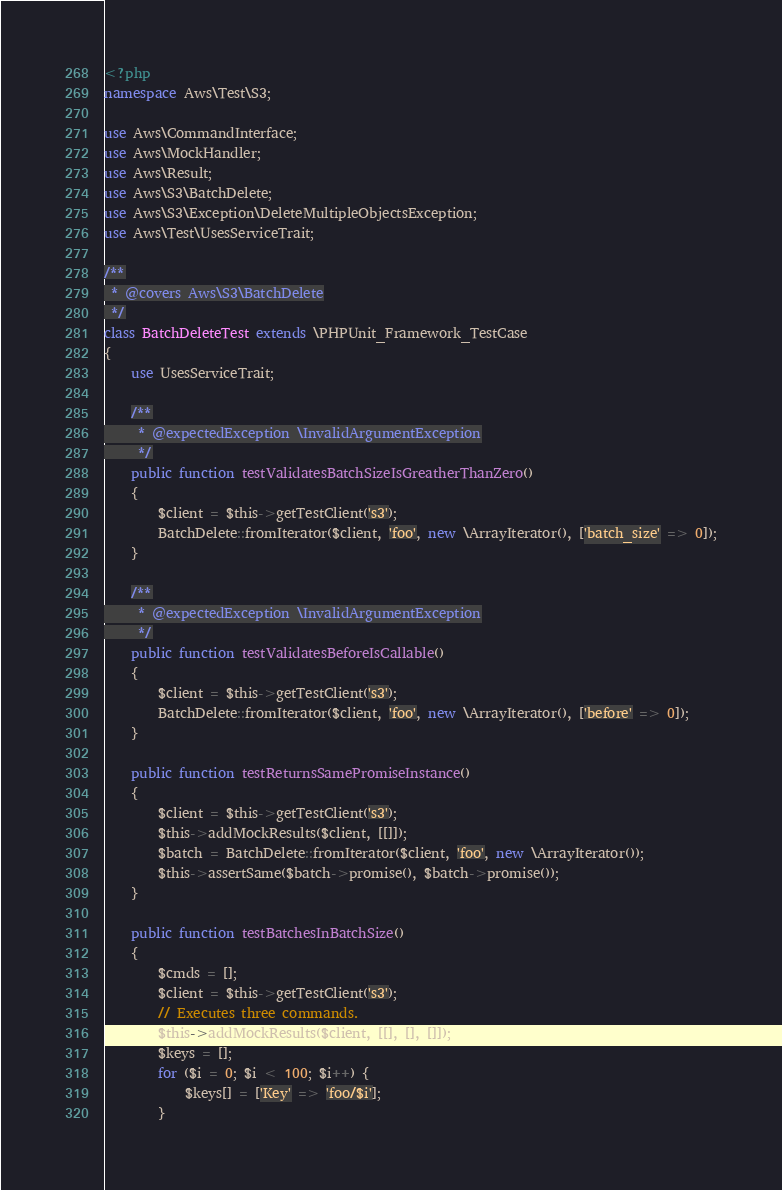Convert code to text. <code><loc_0><loc_0><loc_500><loc_500><_PHP_><?php
namespace Aws\Test\S3;

use Aws\CommandInterface;
use Aws\MockHandler;
use Aws\Result;
use Aws\S3\BatchDelete;
use Aws\S3\Exception\DeleteMultipleObjectsException;
use Aws\Test\UsesServiceTrait;

/**
 * @covers Aws\S3\BatchDelete
 */
class BatchDeleteTest extends \PHPUnit_Framework_TestCase
{
    use UsesServiceTrait;

    /**
     * @expectedException \InvalidArgumentException
     */
    public function testValidatesBatchSizeIsGreatherThanZero()
    {
        $client = $this->getTestClient('s3');
        BatchDelete::fromIterator($client, 'foo', new \ArrayIterator(), ['batch_size' => 0]);
    }

    /**
     * @expectedException \InvalidArgumentException
     */
    public function testValidatesBeforeIsCallable()
    {
        $client = $this->getTestClient('s3');
        BatchDelete::fromIterator($client, 'foo', new \ArrayIterator(), ['before' => 0]);
    }

    public function testReturnsSamePromiseInstance()
    {
        $client = $this->getTestClient('s3');
        $this->addMockResults($client, [[]]);
        $batch = BatchDelete::fromIterator($client, 'foo', new \ArrayIterator());
        $this->assertSame($batch->promise(), $batch->promise());
    }

    public function testBatchesInBatchSize()
    {
        $cmds = [];
        $client = $this->getTestClient('s3');
        // Executes three commands.
        $this->addMockResults($client, [[], [], []]);
        $keys = [];
        for ($i = 0; $i < 100; $i++) {
            $keys[] = ['Key' => 'foo/$i'];
        }
</code> 